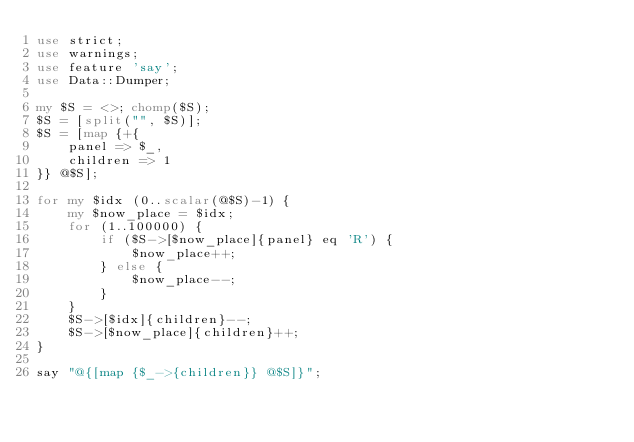Convert code to text. <code><loc_0><loc_0><loc_500><loc_500><_Perl_>use strict;
use warnings;
use feature 'say';
use Data::Dumper;

my $S = <>; chomp($S);
$S = [split("", $S)];
$S = [map {+{
    panel => $_,
    children => 1
}} @$S];

for my $idx (0..scalar(@$S)-1) {
    my $now_place = $idx;
    for (1..100000) {
        if ($S->[$now_place]{panel} eq 'R') {
            $now_place++;
        } else {
            $now_place--;
        }
    }
    $S->[$idx]{children}--;
    $S->[$now_place]{children}++;
}

say "@{[map {$_->{children}} @$S]}";</code> 